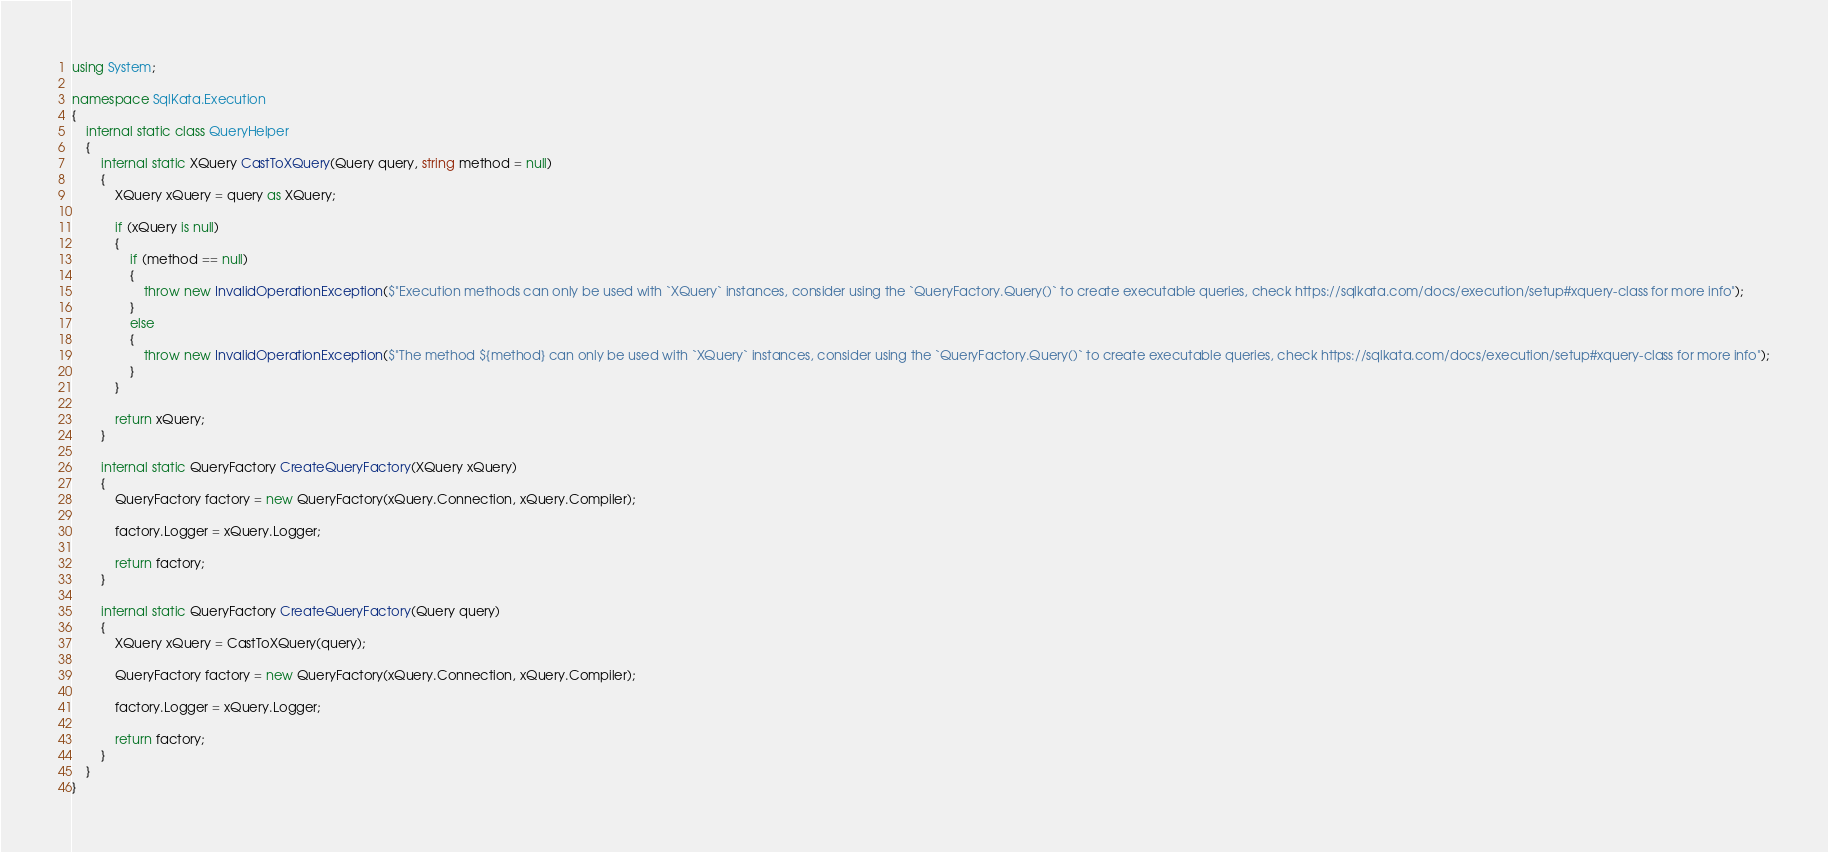Convert code to text. <code><loc_0><loc_0><loc_500><loc_500><_C#_>using System;

namespace SqlKata.Execution
{
    internal static class QueryHelper
    {
        internal static XQuery CastToXQuery(Query query, string method = null)
        {
            XQuery xQuery = query as XQuery;

            if (xQuery is null)
            {
                if (method == null)
                {
                    throw new InvalidOperationException($"Execution methods can only be used with `XQuery` instances, consider using the `QueryFactory.Query()` to create executable queries, check https://sqlkata.com/docs/execution/setup#xquery-class for more info");
                }
                else
                {
                    throw new InvalidOperationException($"The method ${method} can only be used with `XQuery` instances, consider using the `QueryFactory.Query()` to create executable queries, check https://sqlkata.com/docs/execution/setup#xquery-class for more info");
                }
            }

            return xQuery;
        }

        internal static QueryFactory CreateQueryFactory(XQuery xQuery)
        {
            QueryFactory factory = new QueryFactory(xQuery.Connection, xQuery.Compiler);

            factory.Logger = xQuery.Logger;

            return factory;
        }

        internal static QueryFactory CreateQueryFactory(Query query)
        {
            XQuery xQuery = CastToXQuery(query);

            QueryFactory factory = new QueryFactory(xQuery.Connection, xQuery.Compiler);

            factory.Logger = xQuery.Logger;

            return factory;
        }
    }
}</code> 